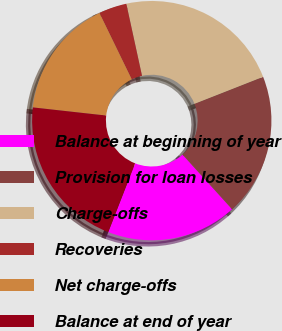Convert chart. <chart><loc_0><loc_0><loc_500><loc_500><pie_chart><fcel>Balance at beginning of year<fcel>Provision for loan losses<fcel>Charge-offs<fcel>Recoveries<fcel>Net charge-offs<fcel>Balance at end of year<nl><fcel>17.64%<fcel>19.24%<fcel>22.45%<fcel>3.79%<fcel>16.03%<fcel>20.84%<nl></chart> 